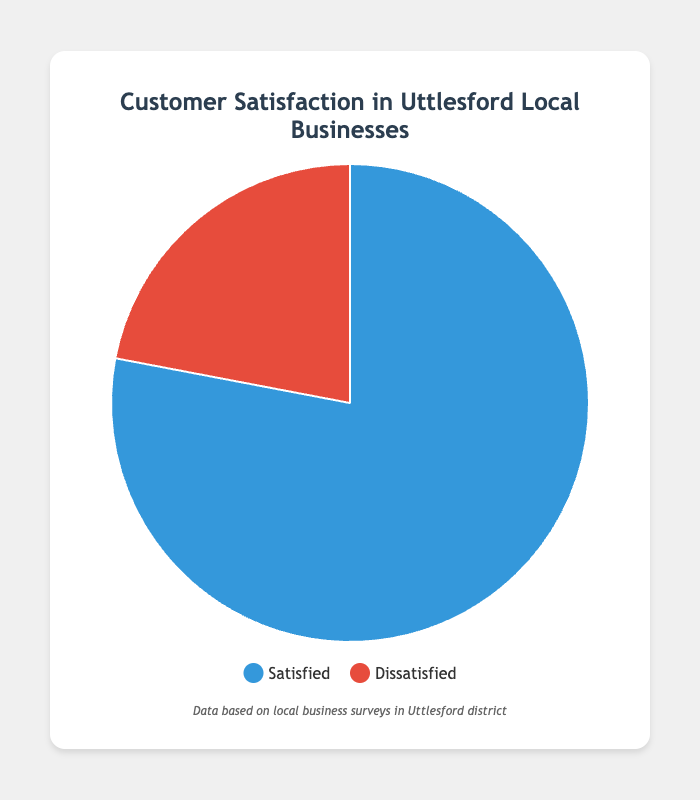Which category has the higher percentage of customers? The chart shows two categories: Satisfied Customers and Dissatisfied Customers. According to the pie chart, the category 'Satisfied Customers' has a higher percentage compared to the 'Dissatisfied Customers'.
Answer: Satisfied Customers What percentage of customers are dissatisfied with local businesses? The pie chart displays two percentages: 78% for Satisfied Customers and 22% for Dissatisfied Customers. The slice representing dissatisfied customers is labeled 22%.
Answer: 22% How many times larger is the percentage of satisfied customers compared to dissatisfied customers? The percentage of satisfied customers is 78%, and the percentage of dissatisfied customers is 22%. To find how many times larger 78% is compared to 22%, we divide 78 by 22, which gives approximately 3.54.
Answer: 3.54 times larger What is the combined percentage of satisfied and dissatisfied customers? The chart shows that there are only two categories: Satisfied Customers (78%) and Dissatisfied Customers (22%). Adding these together, 78% + 22%, gives a total of 100%.
Answer: 100% If you removed the percentage of dissatisfied customers, what percentage would represent satisfied customers out of the remaining customers? The chart shows that there are 78% satisfied customers and 22% dissatisfied customers. If you remove the 22% dissatisfied customers, the remaining percentage is 78%. Satisfied customers would then represent 100% of the remaining customers.
Answer: 100% What would be the change in percentage if the number of satisfied customers decreased by 10%? If the satisfied customers decreased by 10% from 78%, the new percentage of satisfied customers would be 78% - 10% = 68%. Consequently, the dissatisfied customers' percentage would need to cover the reduced portion, which would be 22% + 10% = 32%.
Answer: 68% satisfied, 32% dissatisfied Is the proportion of satisfied customers more than three times the proportion of dissatisfied customers? The chart shows that the proportion of satisfied customers is 78% and dissatisfied customers is 22%. By dividing 78 by 22, we get approximately 3.54, which confirms that the proportion of satisfied customers is more than three times the proportion of dissatisfied customers.
Answer: Yes What colour represents the satisfied customers on the pie chart? The legend associated with the chart shows that satisfied customers are represented by the color blue.
Answer: Blue By how much does the percentage of satisfied customers exceed that of dissatisfied customers? The chart shows 78% satisfied customers and 22% dissatisfied customers. Subtracting the percentage of dissatisfied customers from satisfied customers (78% - 22%) gives 56%.
Answer: 56% 